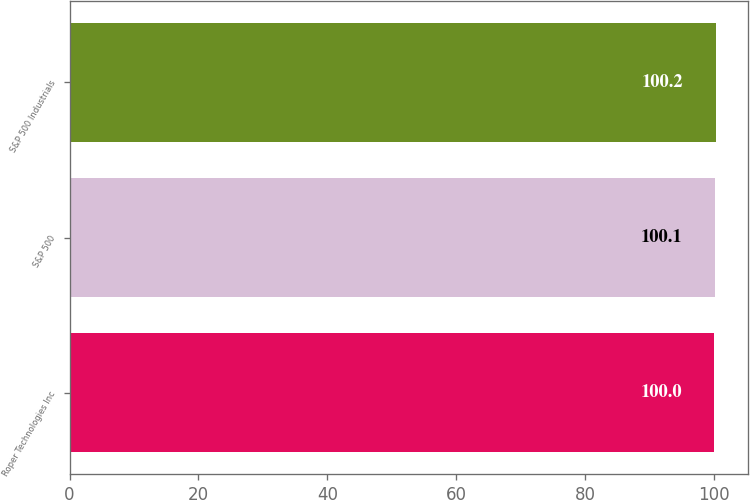Convert chart. <chart><loc_0><loc_0><loc_500><loc_500><bar_chart><fcel>Roper Technologies Inc<fcel>S&P 500<fcel>S&P 500 Industrials<nl><fcel>100<fcel>100.1<fcel>100.2<nl></chart> 